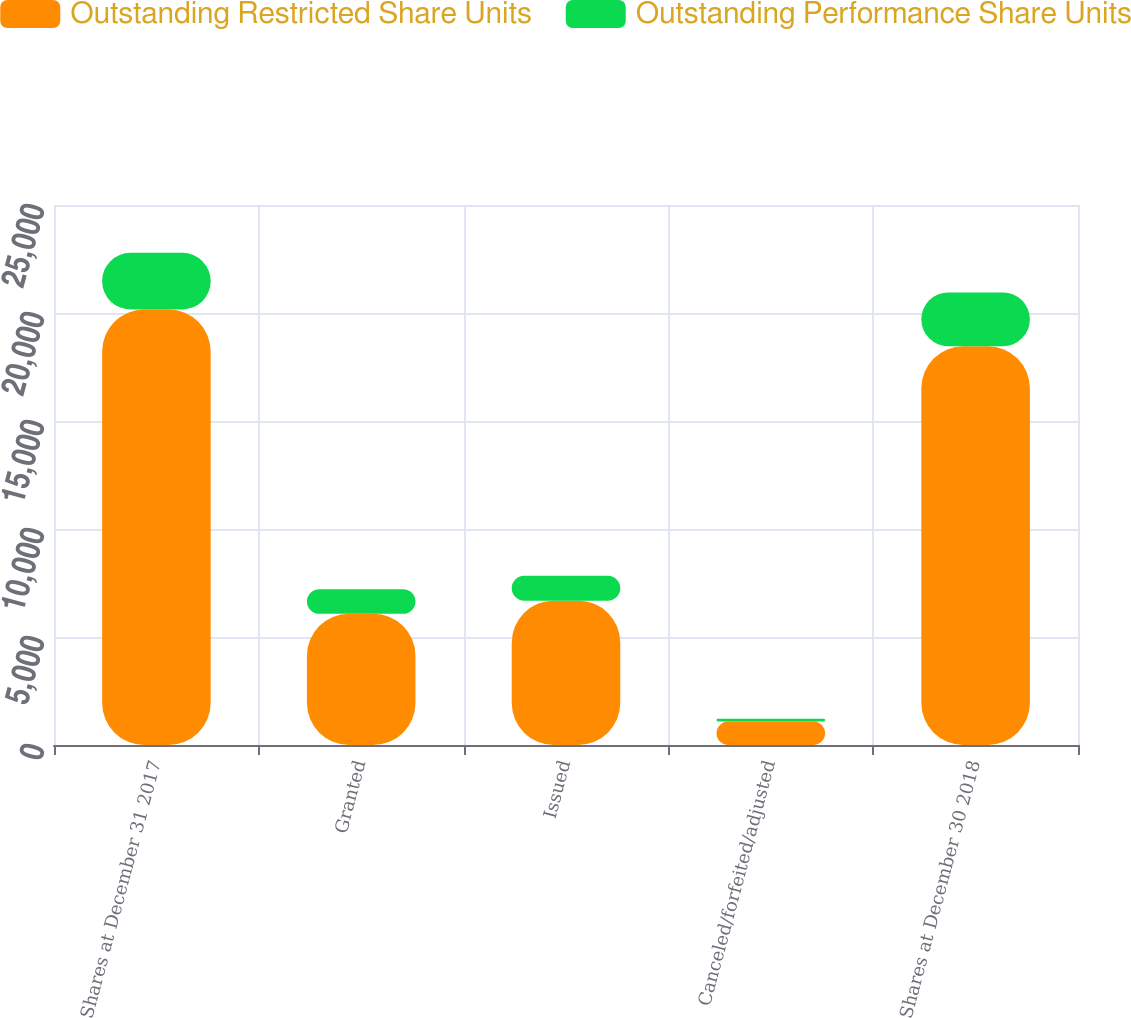Convert chart to OTSL. <chart><loc_0><loc_0><loc_500><loc_500><stacked_bar_chart><ecel><fcel>Shares at December 31 2017<fcel>Granted<fcel>Issued<fcel>Canceled/forfeited/adjusted<fcel>Shares at December 30 2018<nl><fcel>Outstanding Restricted Share Units<fcel>20161<fcel>6074<fcel>6684<fcel>1091<fcel>18460<nl><fcel>Outstanding Performance Share Units<fcel>2625<fcel>1142<fcel>1151<fcel>122<fcel>2494<nl></chart> 